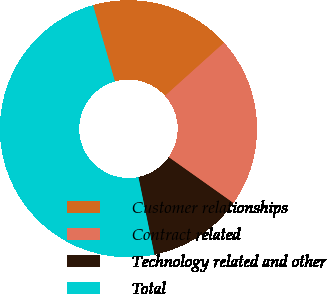Convert chart. <chart><loc_0><loc_0><loc_500><loc_500><pie_chart><fcel>Customer relationships<fcel>Contract related<fcel>Technology related and other<fcel>Total<nl><fcel>17.79%<fcel>21.47%<fcel>11.96%<fcel>48.77%<nl></chart> 